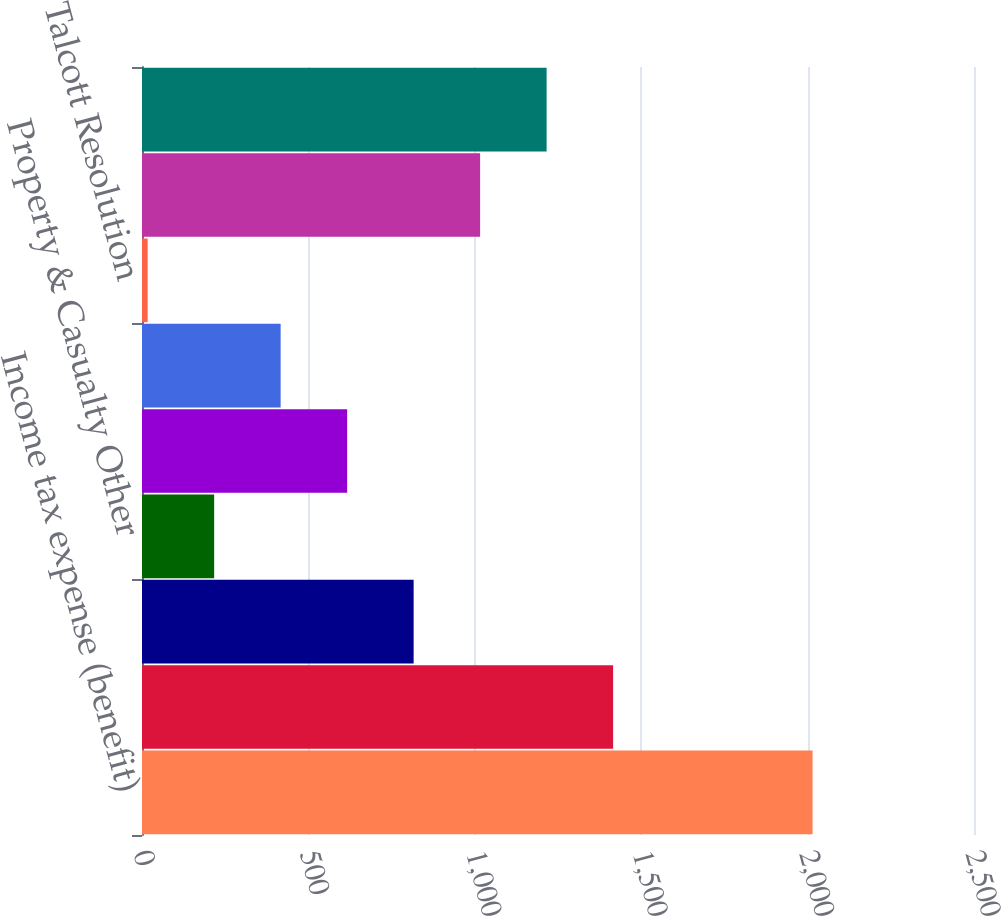Convert chart. <chart><loc_0><loc_0><loc_500><loc_500><bar_chart><fcel>Income tax expense (benefit)<fcel>Commercial Lines<fcel>Personal Lines<fcel>Property & Casualty Other<fcel>Group Benefits<fcel>Mutual Funds<fcel>Talcott Resolution<fcel>Corporate<fcel>Total income tax expense<nl><fcel>2015<fcel>1415.6<fcel>816.2<fcel>216.8<fcel>616.4<fcel>416.6<fcel>17<fcel>1016<fcel>1215.8<nl></chart> 